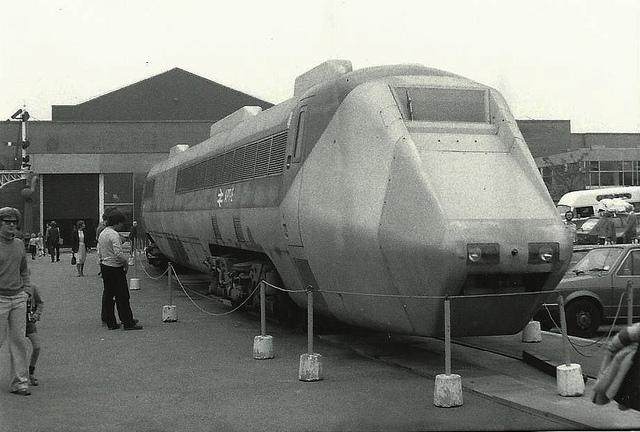Where is this train located? Please explain your reasoning. museum. The train is not on a track and it has a rope around it to protect it from people and there are people looking at it. 